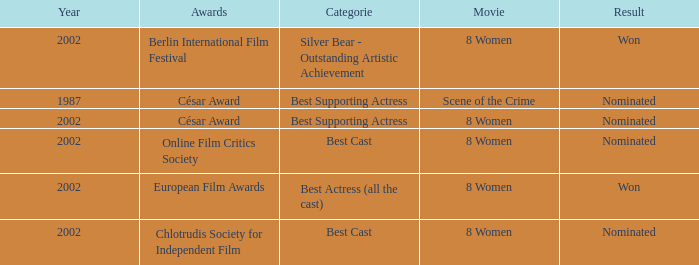What was the result at the Berlin International Film Festival in a year greater than 1987? Won. 